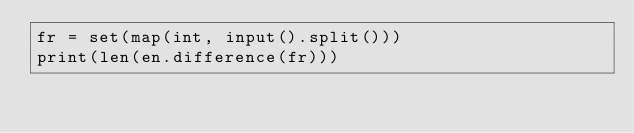Convert code to text. <code><loc_0><loc_0><loc_500><loc_500><_Python_>fr = set(map(int, input().split()))
print(len(en.difference(fr))) 
</code> 